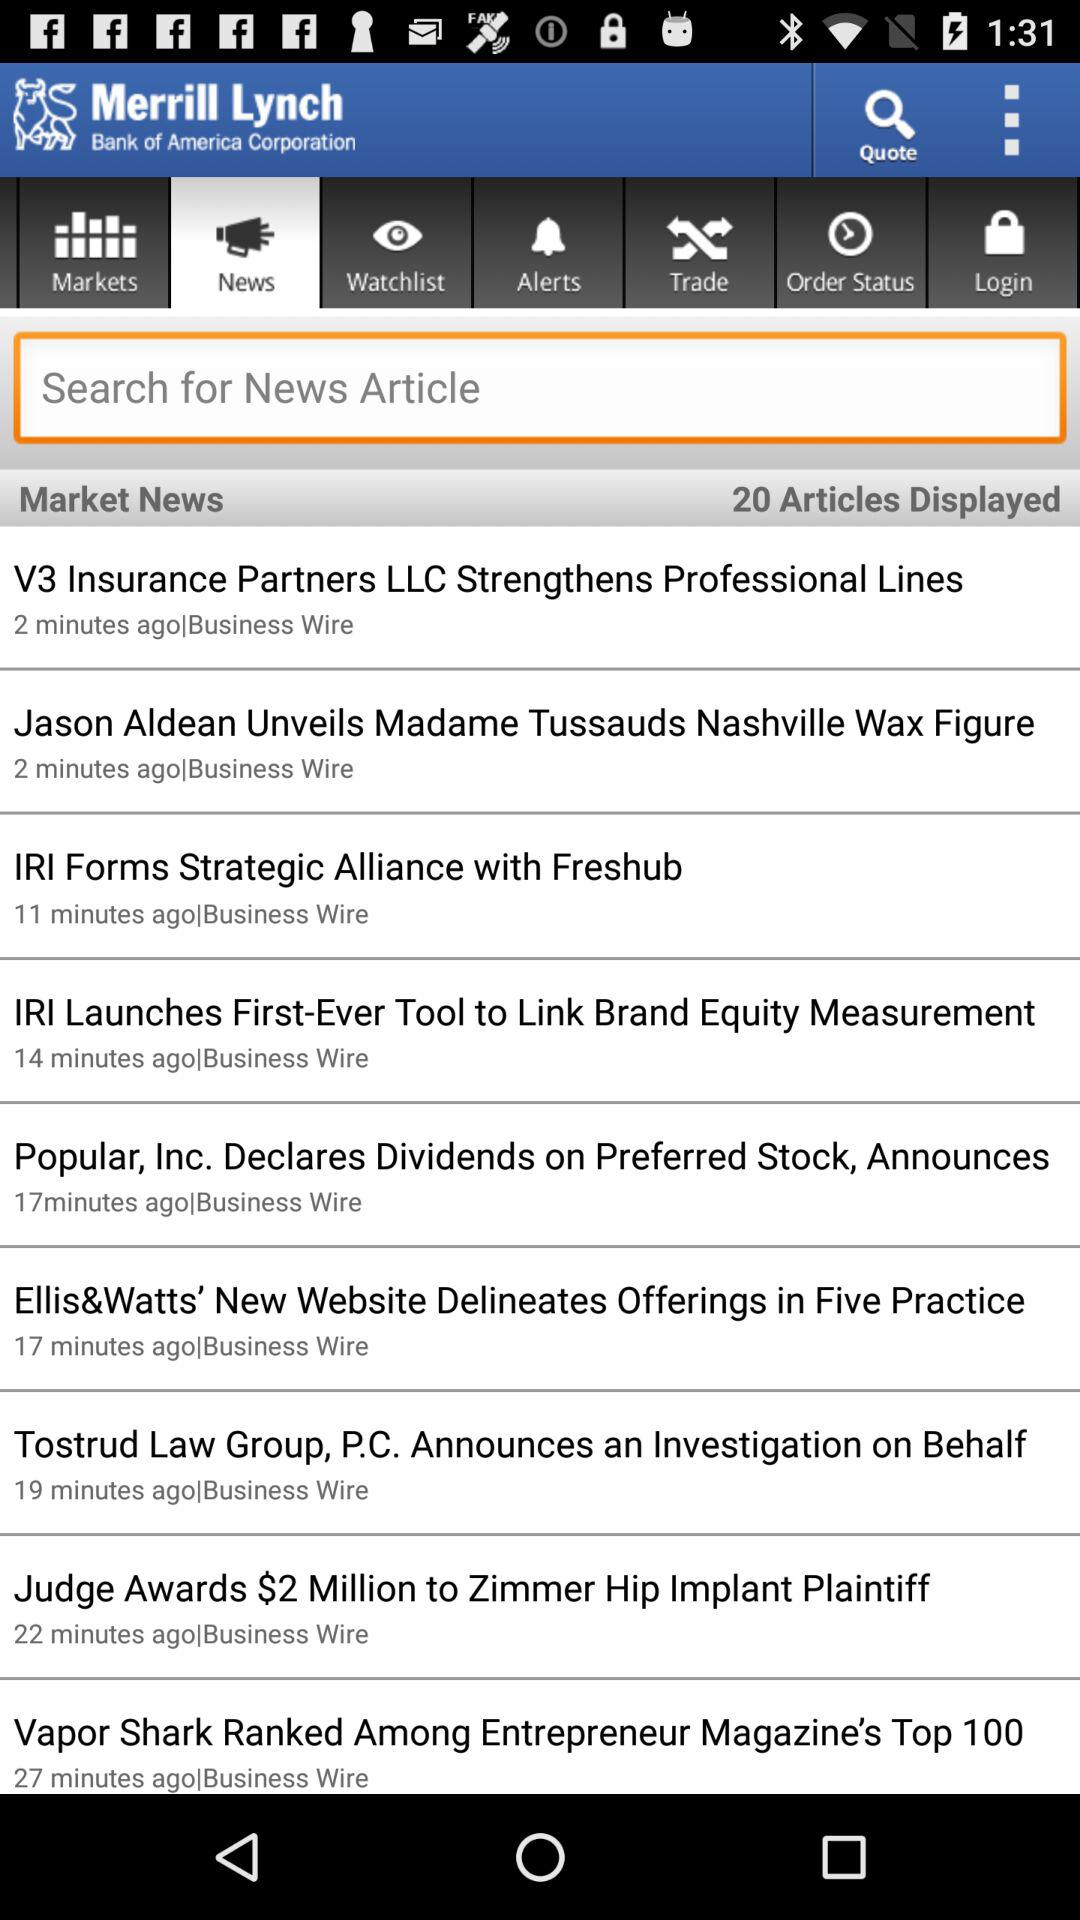Who unveils Madame Tussauds Nashville Wax Figure? It is unveiled by Jason Aldean. 